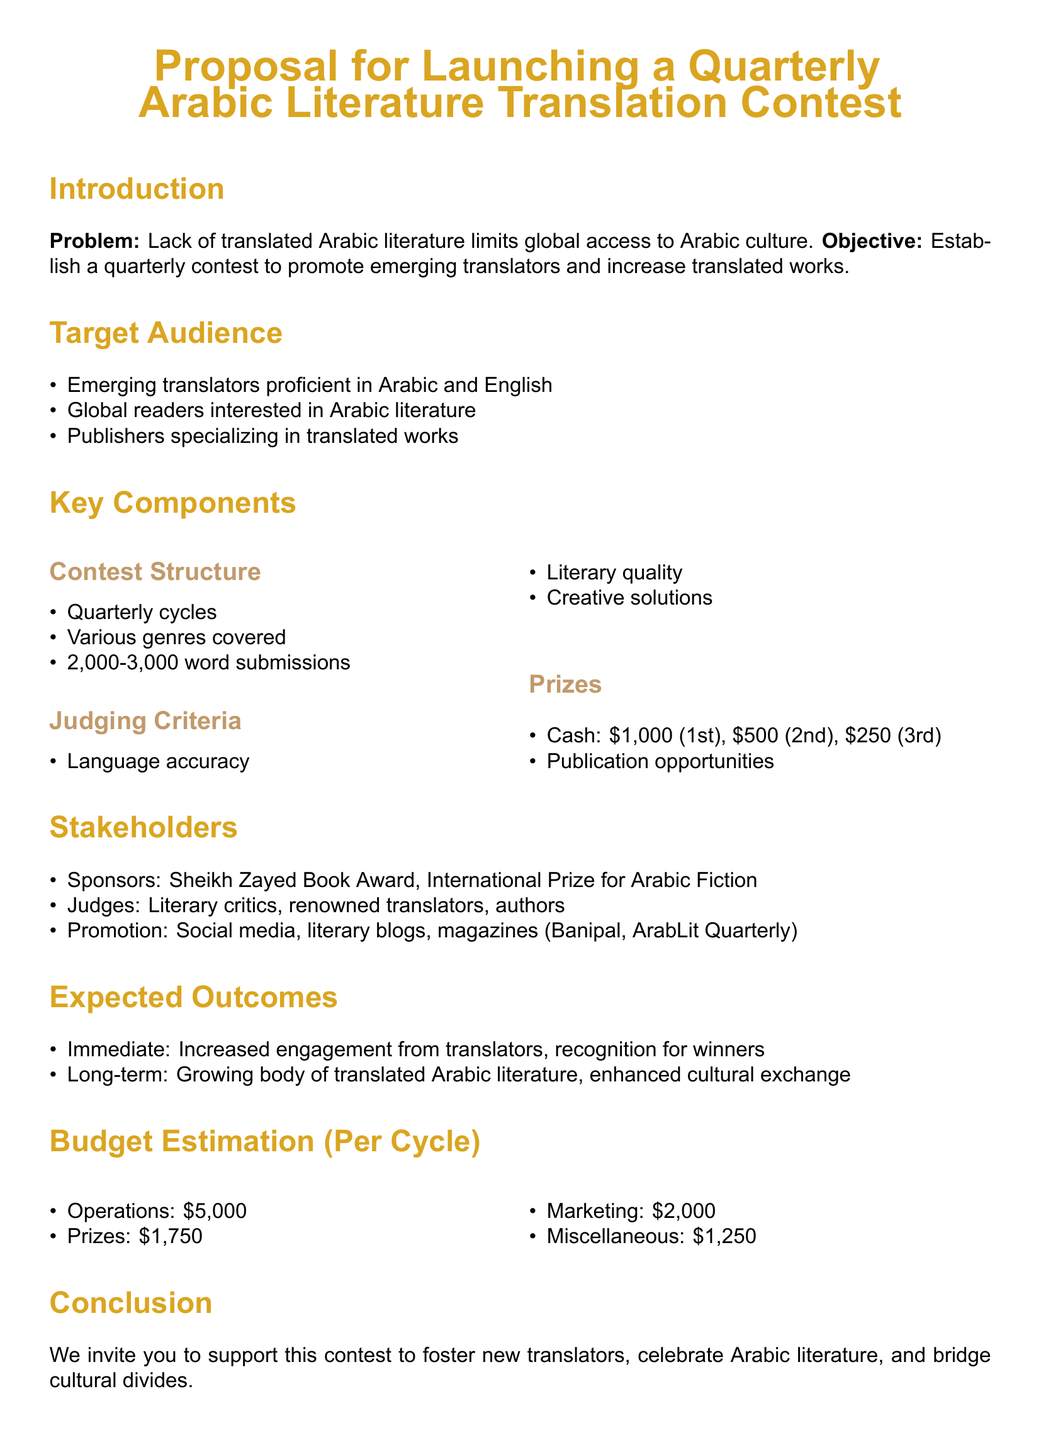What is the prize for the first place winner? The document lists the prizes, stating that the first place winner receives $1,000.
Answer: $1,000 How often will the contest be held? The proposal mentions a quarterly contest, indicating it will occur four times a year.
Answer: Quarterly What is the maximum word count for submissions? The submission guidelines specify that submissions should be between 2,000 to 3,000 words.
Answer: 3,000 words Which organizations are listed as sponsors? The proposal identifies the Sheikh Zayed Book Award and the International Prize for Arabic Fiction as sponsors.
Answer: Sheikh Zayed Book Award, International Prize for Arabic Fiction What is one of the judging criteria? The document states that language accuracy is one of the criteria for judging submissions.
Answer: Language accuracy What is the estimated budget for marketing per cycle? The budget section indicates that $2,000 is allocated for marketing in each cycle.
Answer: $2,000 What do the expected outcomes include? The document outlines immediate and long-term expected outcomes, including increased engagement and a growing body of translated literature.
Answer: Increased engagement, growing body of translated Arabic literature Which literary magazines are mentioned for promotion? The proposal lists Banipal and ArabLit Quarterly as platforms for promoting the contest.
Answer: Banipal, ArabLit Quarterly 